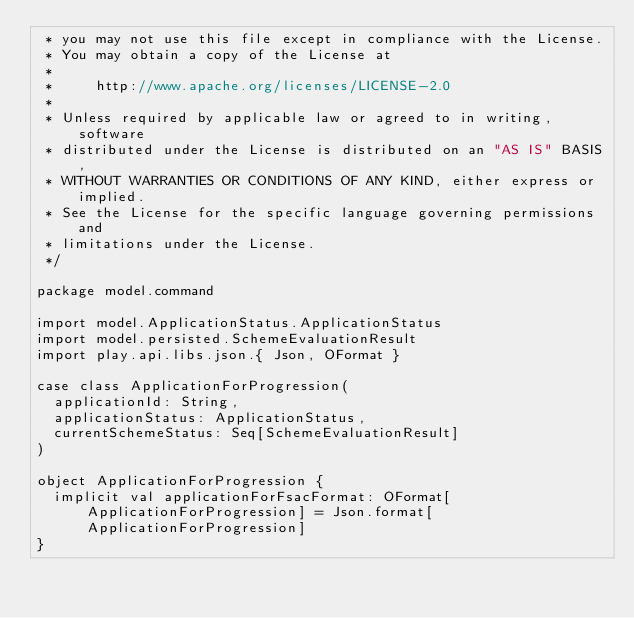Convert code to text. <code><loc_0><loc_0><loc_500><loc_500><_Scala_> * you may not use this file except in compliance with the License.
 * You may obtain a copy of the License at
 *
 *     http://www.apache.org/licenses/LICENSE-2.0
 *
 * Unless required by applicable law or agreed to in writing, software
 * distributed under the License is distributed on an "AS IS" BASIS,
 * WITHOUT WARRANTIES OR CONDITIONS OF ANY KIND, either express or implied.
 * See the License for the specific language governing permissions and
 * limitations under the License.
 */

package model.command

import model.ApplicationStatus.ApplicationStatus
import model.persisted.SchemeEvaluationResult
import play.api.libs.json.{ Json, OFormat }

case class ApplicationForProgression(
  applicationId: String,
  applicationStatus: ApplicationStatus,
  currentSchemeStatus: Seq[SchemeEvaluationResult]
)

object ApplicationForProgression {
  implicit val applicationForFsacFormat: OFormat[ApplicationForProgression] = Json.format[ApplicationForProgression]
}
</code> 